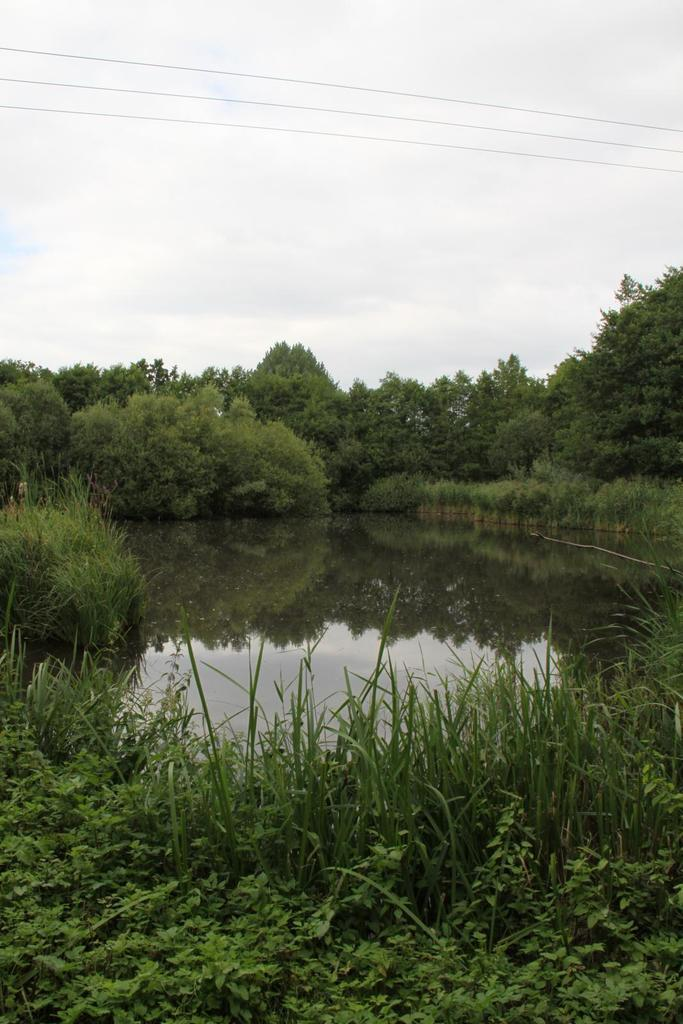What type of vegetation is present in the image? There are many trees in the image. How are the trees arranged in the image? The trees are planted. What type of ground cover is visible in the image? There is grass in the image. What natural element is visible in the image besides trees and grass? There is water visible in the image. What is visible at the top of the image? The sky is visible at the top of the image. What type of underwear is hanging on the trees in the image? There is no underwear present in the image; it only features trees, grass, water, and the sky. 